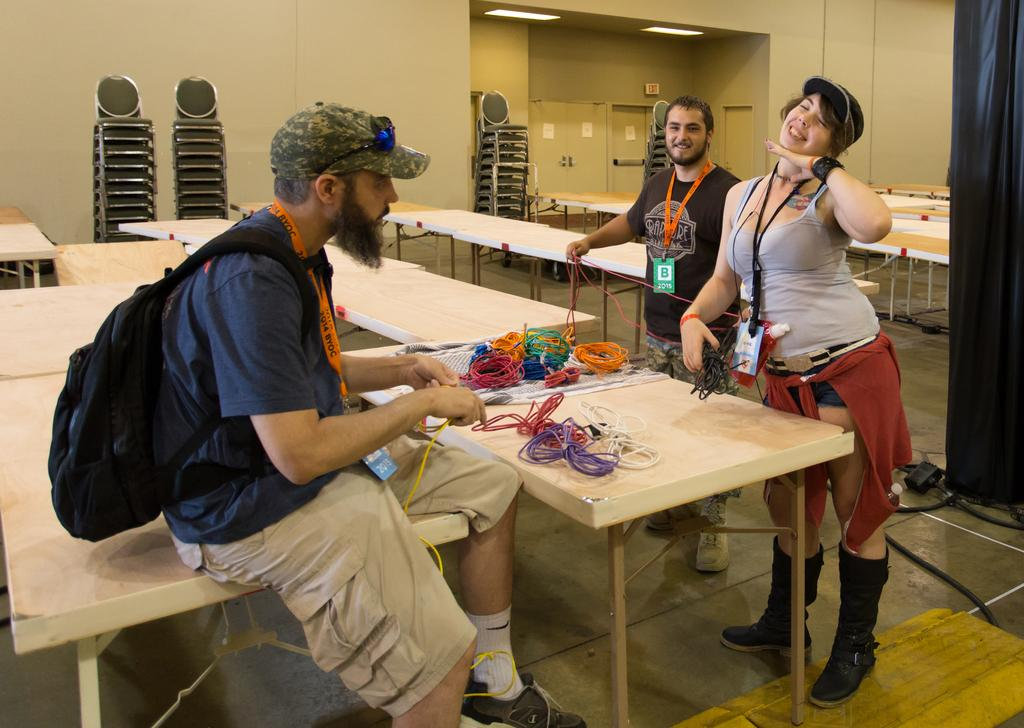How many people are in the image? There are three people in the image: two men and a woman. What is the facial expression of the people in the image? The men and woman are smiling in the image. What type of furniture is present in the image? There are multiple tables and chairs in the image. What can be found on the table(s) in the image? There are objects on the table(s) in the image. What type of advertisement can be seen on the woman's shirt in the image? There is no advertisement visible on the woman's shirt in the image. What type of material is the bee sitting on in the image? There are no bees present in the image. 